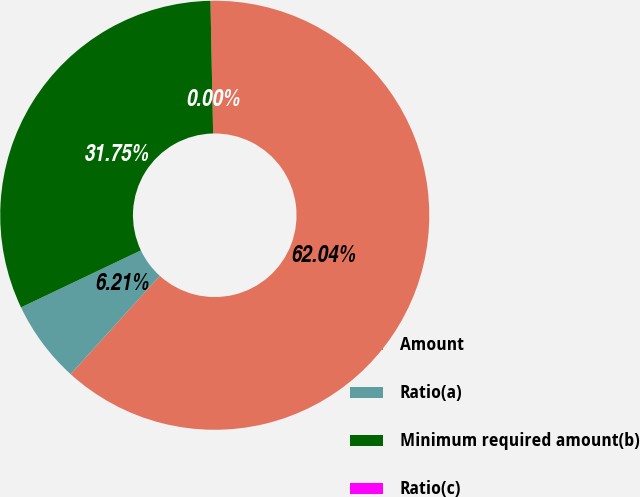Convert chart to OTSL. <chart><loc_0><loc_0><loc_500><loc_500><pie_chart><fcel>Amount<fcel>Ratio(a)<fcel>Minimum required amount(b)<fcel>Ratio(c)<nl><fcel>62.05%<fcel>6.21%<fcel>31.75%<fcel>0.0%<nl></chart> 